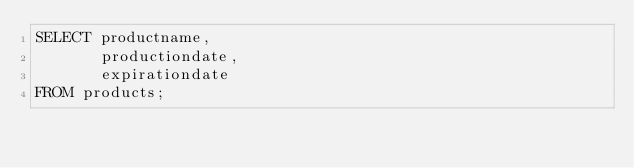<code> <loc_0><loc_0><loc_500><loc_500><_SQL_>SELECT productname, 
       productiondate, 
       expirationdate
FROM products;
</code> 